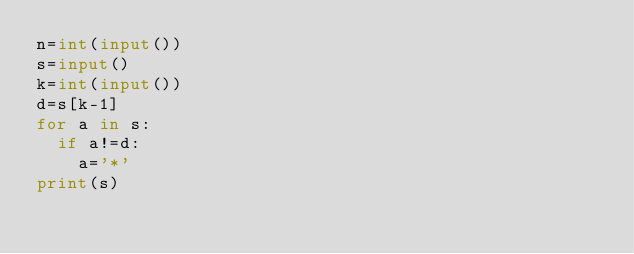<code> <loc_0><loc_0><loc_500><loc_500><_Python_>n=int(input())
s=input()
k=int(input())
d=s[k-1]
for a in s:
  if a!=d:
    a='*'
print(s)</code> 